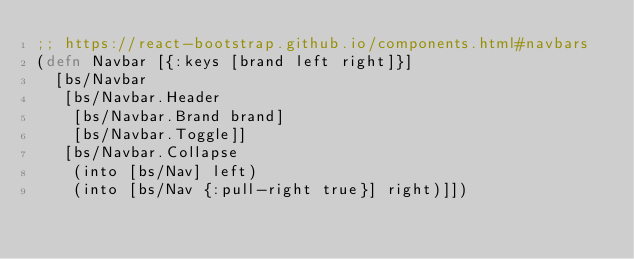<code> <loc_0><loc_0><loc_500><loc_500><_Clojure_>;; https://react-bootstrap.github.io/components.html#navbars
(defn Navbar [{:keys [brand left right]}]
  [bs/Navbar
   [bs/Navbar.Header
    [bs/Navbar.Brand brand]
    [bs/Navbar.Toggle]]
   [bs/Navbar.Collapse
    (into [bs/Nav] left)
    (into [bs/Nav {:pull-right true}] right)]])

</code> 